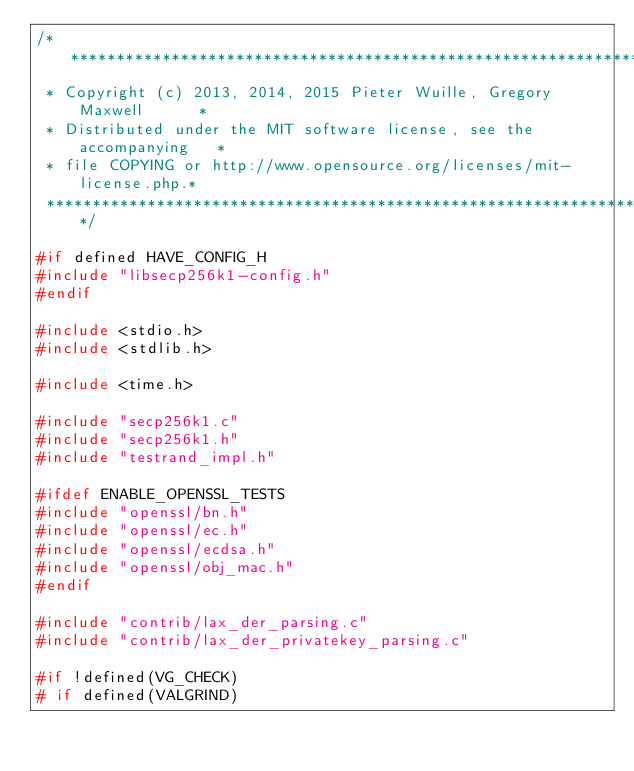Convert code to text. <code><loc_0><loc_0><loc_500><loc_500><_C_>/**********************************************************************
 * Copyright (c) 2013, 2014, 2015 Pieter Wuille, Gregory Maxwell      *
 * Distributed under the MIT software license, see the accompanying   *
 * file COPYING or http://www.opensource.org/licenses/mit-license.php.*
 **********************************************************************/

#if defined HAVE_CONFIG_H
#include "libsecp256k1-config.h"
#endif

#include <stdio.h>
#include <stdlib.h>

#include <time.h>

#include "secp256k1.c"
#include "secp256k1.h"
#include "testrand_impl.h"

#ifdef ENABLE_OPENSSL_TESTS
#include "openssl/bn.h"
#include "openssl/ec.h"
#include "openssl/ecdsa.h"
#include "openssl/obj_mac.h"
#endif

#include "contrib/lax_der_parsing.c"
#include "contrib/lax_der_privatekey_parsing.c"

#if !defined(VG_CHECK)
# if defined(VALGRIND)</code> 